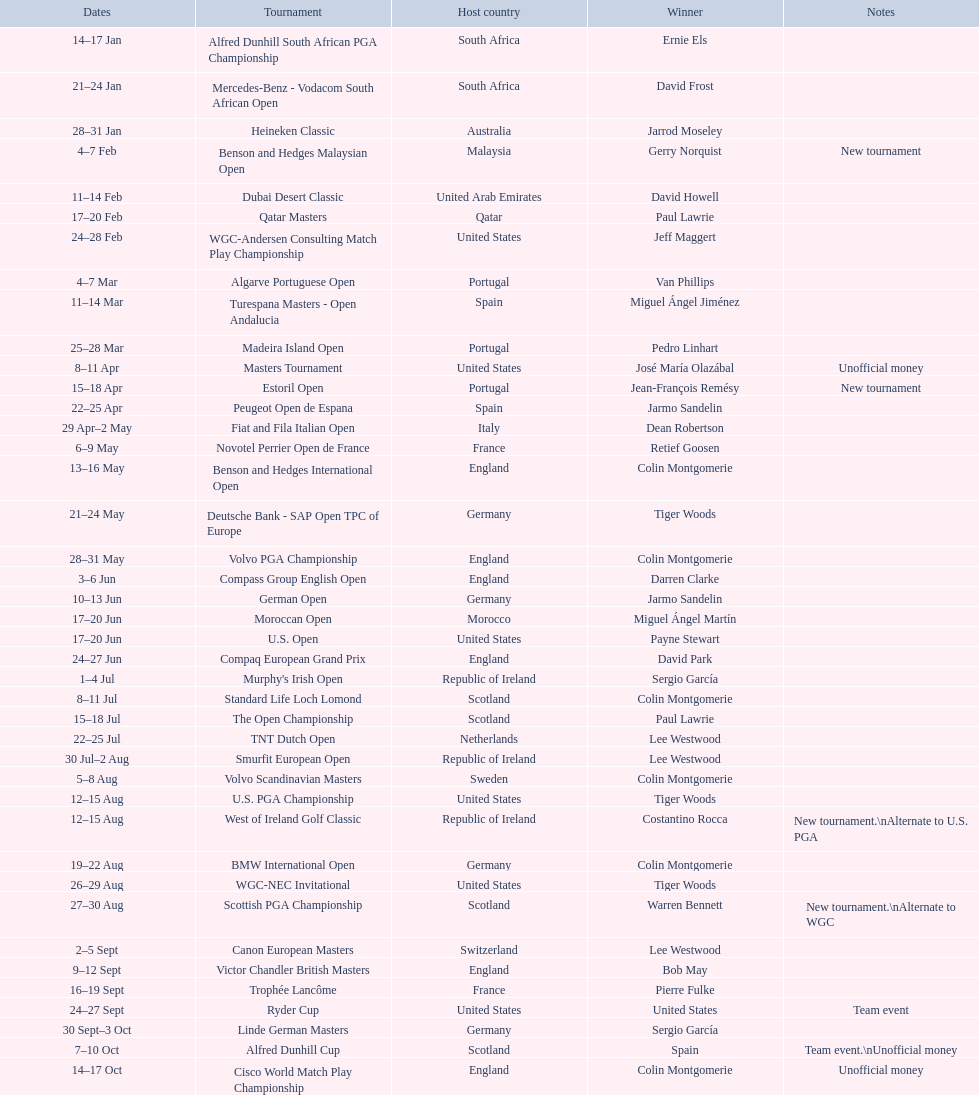Does any nation possess more than 5 victors? Yes. 